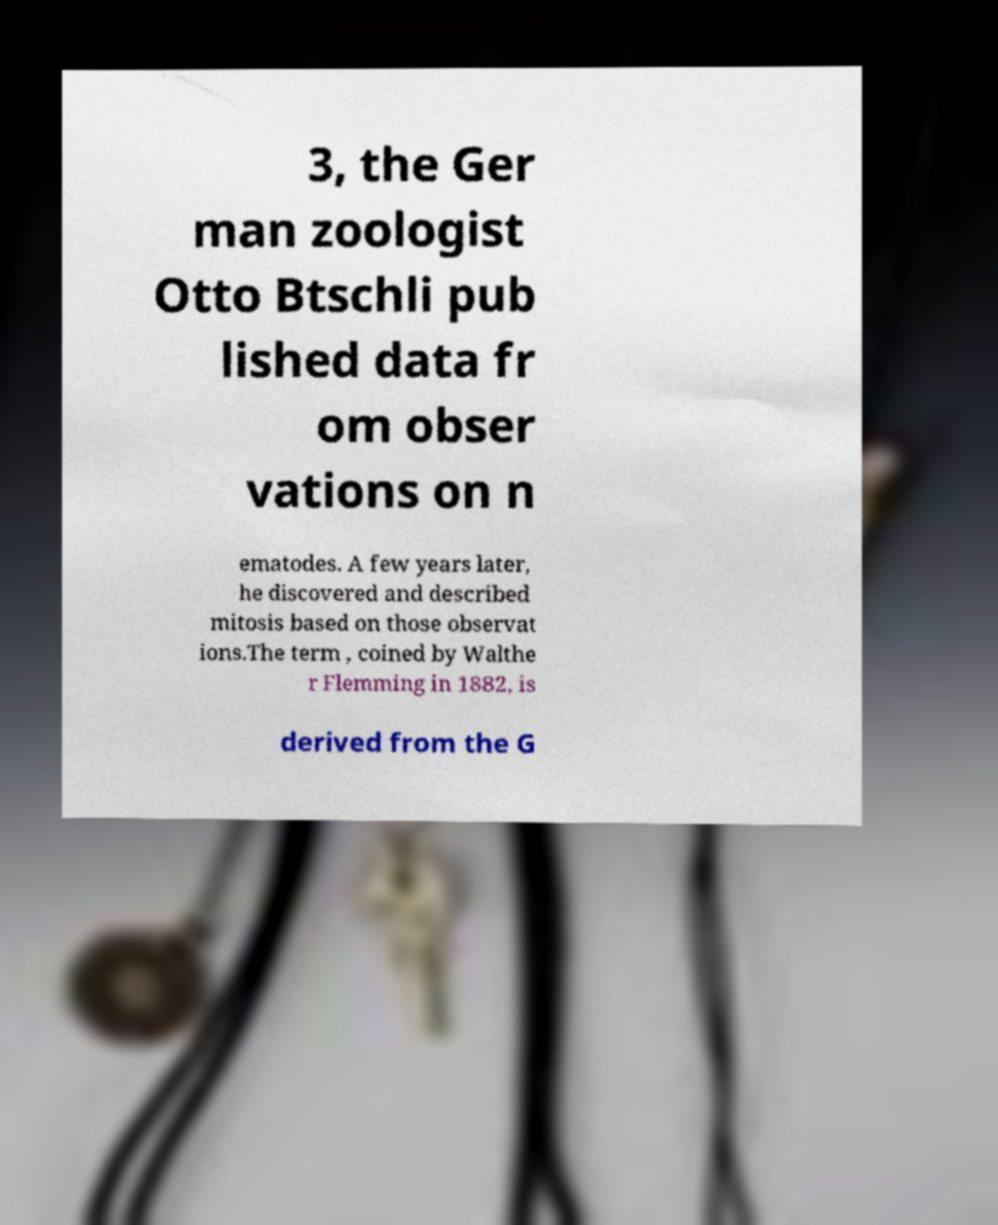Could you assist in decoding the text presented in this image and type it out clearly? 3, the Ger man zoologist Otto Btschli pub lished data fr om obser vations on n ematodes. A few years later, he discovered and described mitosis based on those observat ions.The term , coined by Walthe r Flemming in 1882, is derived from the G 